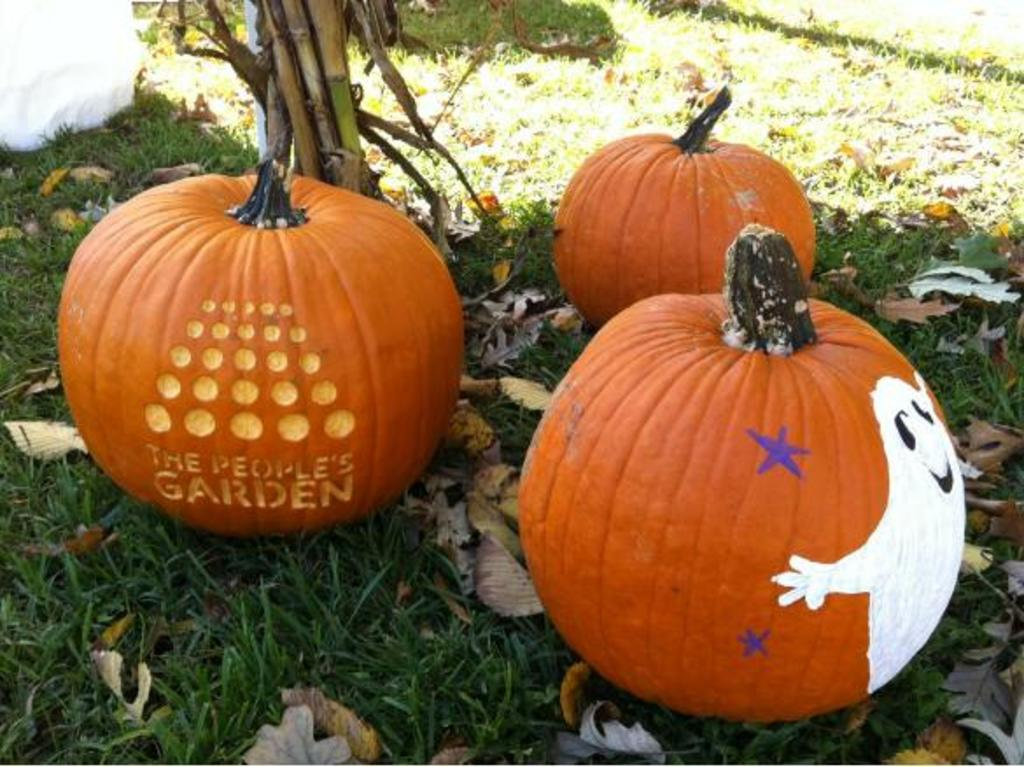What type of vegetable is present in the image? There are pumpkins in the image. Where are the pumpkins located? The pumpkins are kept on a grassy land. What part of the pumpkins is visible in the image? The image shows stems at the top of the pumpkins. How many mice are hiding behind the pumpkins in the image? There are no mice present in the image. What type of mask is worn by the pumpkins in the image? The pumpkins in the image are not wearing any masks. 